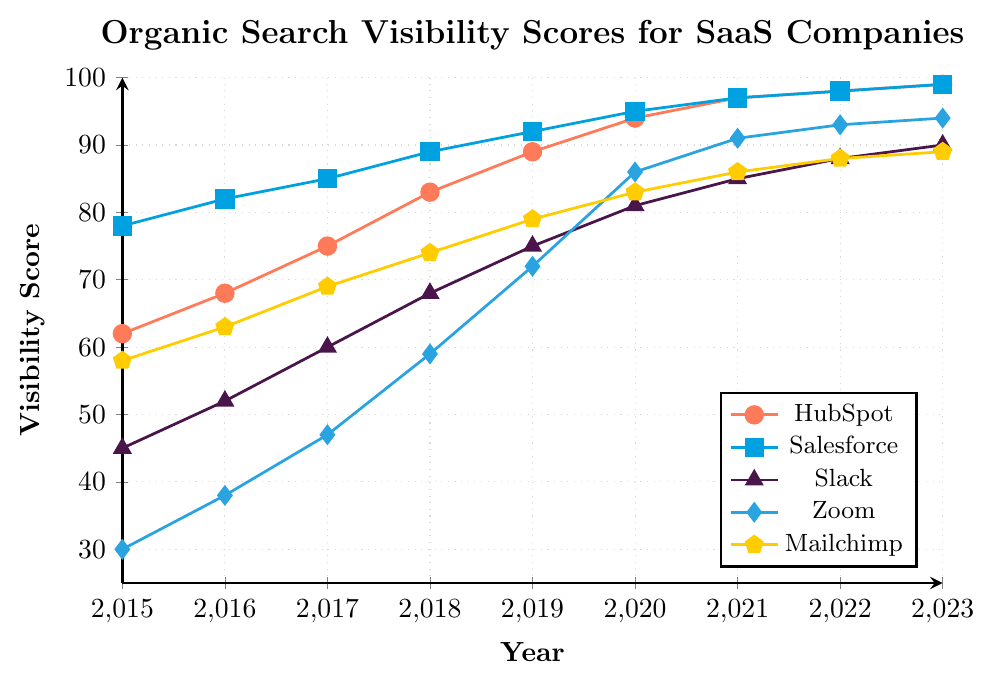Which company had the highest organic search visibility score in 2015? To answer this question, look at the visibility scores for all companies in 2015. The company with the highest score is Salesforce with a score of 78.
Answer: Salesforce What is the rate of change in visibility score for Zoom between 2015 and 2023? To calculate the rate of change, take the difference in scores between 2023 and 2015, then divide by the number of years between them: (94 - 30) / (2023 - 2015) = 64 / 8, which is 8 points per year.
Answer: 8 points per year Did any company have a consistent increase in visibility score every year from 2015 to 2023? To determine this, check if there is any consistent increase in scores for each company every year. All companies (HubSpot, Salesforce, Slack, Zoom, Mailchimp) have consistent yearly increase in visibility scores.
Answer: Yes, all companies By how much did Mailchimp's visibility score increase from 2015 to 2023? To find the increase, subtract Mailchimp's 2015 score from its 2023 score: 89 - 58 = 31.
Answer: 31 Which two companies had the closest visibility scores in 2023? Compare the 2023 scores for all companies: HubSpot (99), Salesforce (99), Slack (90), Zoom (94), Mailchimp (89). HubSpot and Salesforce both have a score of 99, the closest to each other.
Answer: HubSpot and Salesforce What is the average visibility score for Slack from 2015 to 2023? To find the average, sum all of Slack’s scores from 2015 to 2023 and divide by the number of years: (45 + 52 + 60 + 68 + 75 + 81 + 85 + 88 + 90) / 9 = 644 / 9 ≈ 71.56.
Answer: 71.56 Did any company’s visibility score plateau or stop increasing at any point during 2015-2023? By visually inspecting the graph for flat lines indicating no change, it is evident that both HubSpot and Salesforce's scores plateau at 97 in 2021 and 98 in 2022.
Answer: Yes, HubSpot and Salesforce Compare the visibility score increase of HubSpot and Zoom from 2015 to 2023. Which company's score increased more? Calculate the increase for both companies: HubSpot (99 - 62 = 37) and Zoom (94 - 30 = 64). Zoom’s score increased more.
Answer: Zoom How much higher was Salesforce's visibility score compared to Slack's in 2018? Subtract Slack's 2018 score from Salesforce's 2018 score: 89 - 68 = 21.
Answer: 21 What year did Zoom surpass a visibility score of 80? By checking the graph, Zoom’s visibility score surpasses 80 in the year 2020.
Answer: 2020 